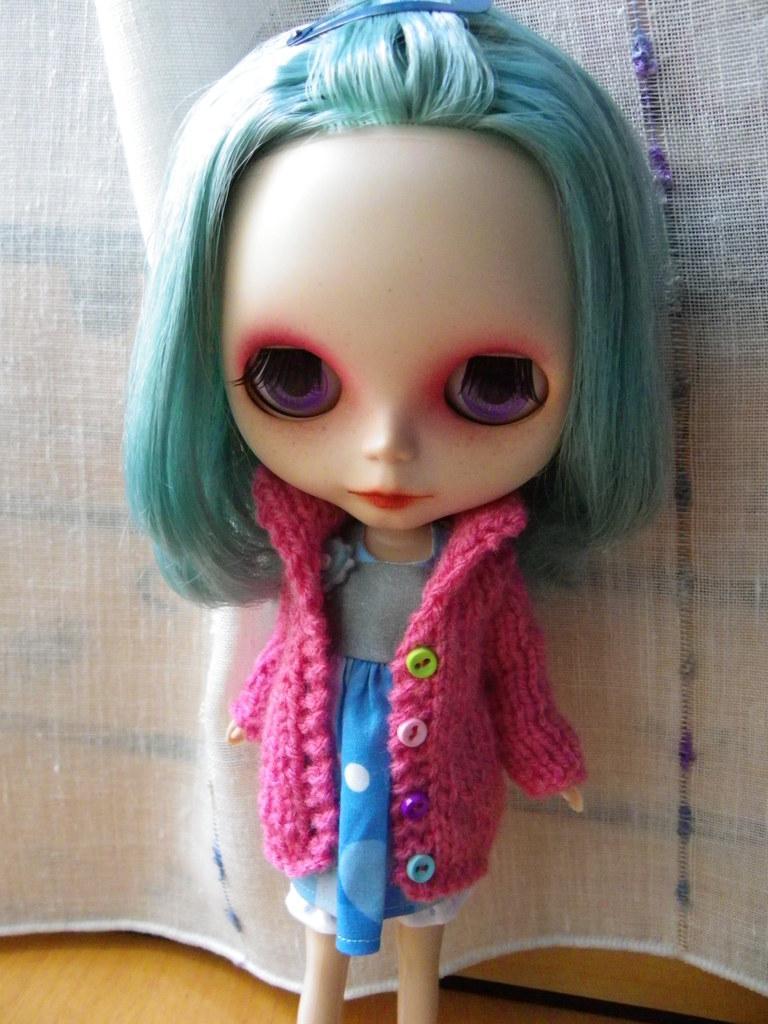In one or two sentences, can you explain what this image depicts? In this image, we can see a doll. At the bottom of the image, we can see a wooden surface and object. Behind the doll, there is a curtain. 